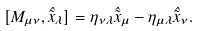Convert formula to latex. <formula><loc_0><loc_0><loc_500><loc_500>[ M _ { \mu \nu } , \hat { \tilde { x } } _ { \lambda } ] = \eta _ { \nu \lambda } \hat { \tilde { x } } _ { \mu } - \eta _ { \mu \lambda } \hat { \tilde { x } } _ { \nu } .</formula> 